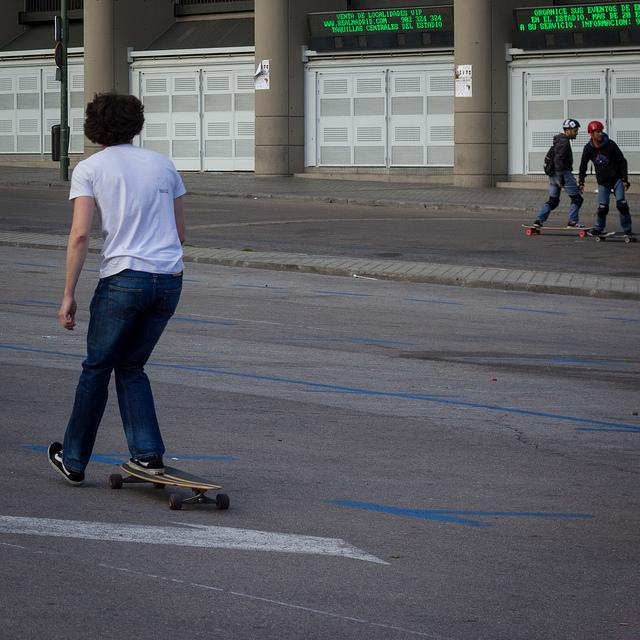What style of skateboard is the man in the white shirt using?

Choices:
A) long board
B) radio board
C) vert board
D) hover board long board 